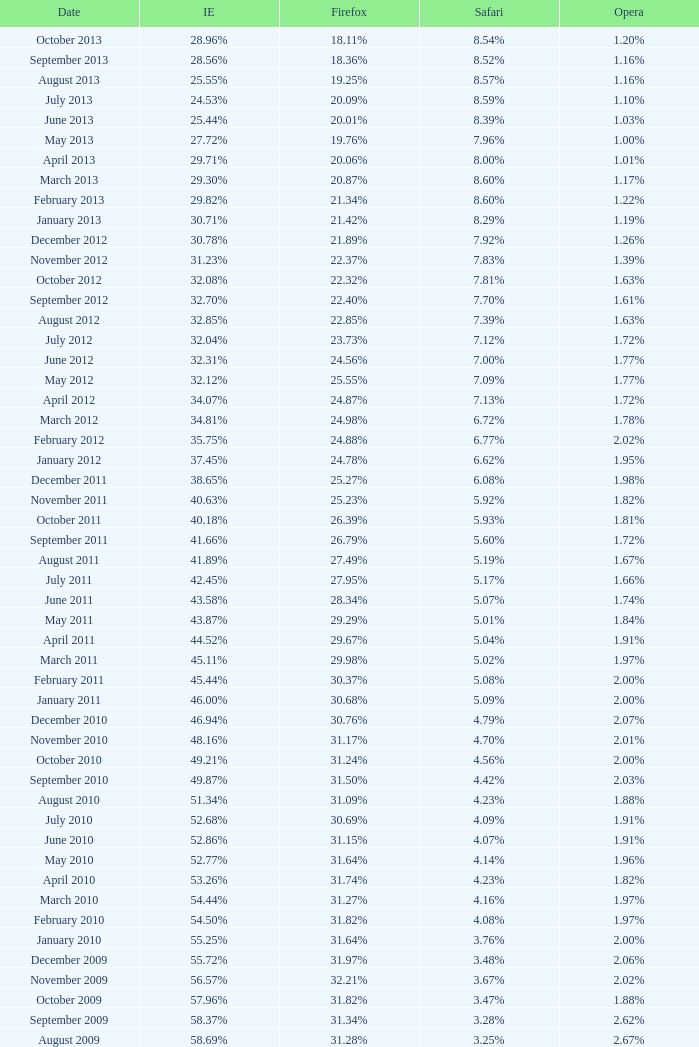What percentage of browsers were using Internet Explorer in April 2009? 61.88%. 